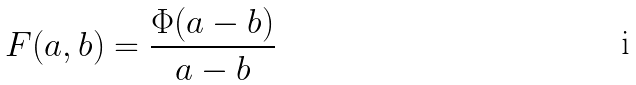<formula> <loc_0><loc_0><loc_500><loc_500>F ( a , b ) = \frac { \Phi ( a - b ) } { a - b }</formula> 